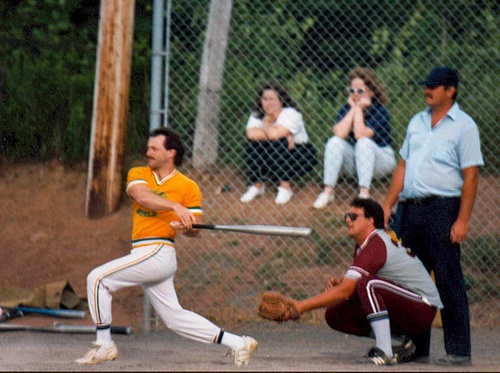Describe the objects in this image and their specific colors. I can see people in black, lightblue, and brown tones, people in black, lightgray, orange, darkgray, and tan tones, people in black, maroon, darkgray, and gray tones, people in black, lightgray, gray, and darkgray tones, and people in black, lightgray, tan, and gray tones in this image. 